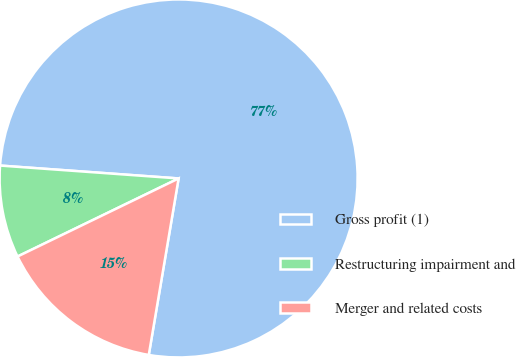Convert chart. <chart><loc_0><loc_0><loc_500><loc_500><pie_chart><fcel>Gross profit (1)<fcel>Restructuring impairment and<fcel>Merger and related costs<nl><fcel>76.52%<fcel>8.33%<fcel>15.15%<nl></chart> 